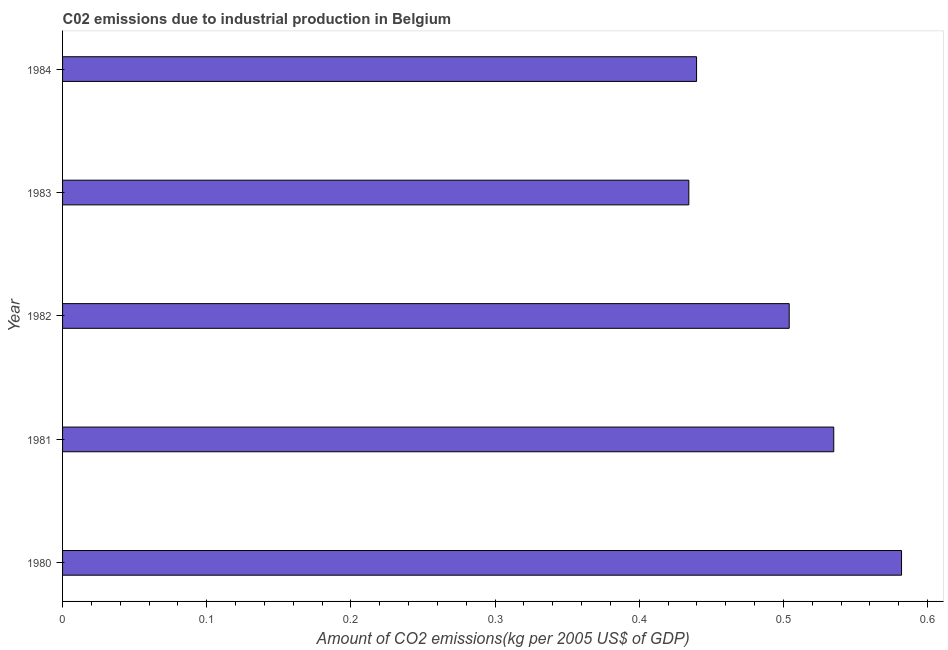Does the graph contain grids?
Provide a short and direct response. No. What is the title of the graph?
Ensure brevity in your answer.  C02 emissions due to industrial production in Belgium. What is the label or title of the X-axis?
Keep it short and to the point. Amount of CO2 emissions(kg per 2005 US$ of GDP). What is the amount of co2 emissions in 1984?
Your answer should be very brief. 0.44. Across all years, what is the maximum amount of co2 emissions?
Provide a succinct answer. 0.58. Across all years, what is the minimum amount of co2 emissions?
Ensure brevity in your answer.  0.43. What is the sum of the amount of co2 emissions?
Offer a very short reply. 2.49. What is the difference between the amount of co2 emissions in 1980 and 1981?
Provide a succinct answer. 0.05. What is the average amount of co2 emissions per year?
Provide a succinct answer. 0.5. What is the median amount of co2 emissions?
Provide a short and direct response. 0.5. Do a majority of the years between 1980 and 1981 (inclusive) have amount of co2 emissions greater than 0.32 kg per 2005 US$ of GDP?
Your answer should be compact. Yes. What is the ratio of the amount of co2 emissions in 1982 to that in 1983?
Provide a succinct answer. 1.16. Is the amount of co2 emissions in 1980 less than that in 1984?
Provide a short and direct response. No. What is the difference between the highest and the second highest amount of co2 emissions?
Offer a very short reply. 0.05. Is the sum of the amount of co2 emissions in 1982 and 1983 greater than the maximum amount of co2 emissions across all years?
Your response must be concise. Yes. What is the difference between the highest and the lowest amount of co2 emissions?
Offer a terse response. 0.15. In how many years, is the amount of co2 emissions greater than the average amount of co2 emissions taken over all years?
Offer a very short reply. 3. Are all the bars in the graph horizontal?
Your answer should be very brief. Yes. What is the Amount of CO2 emissions(kg per 2005 US$ of GDP) in 1980?
Keep it short and to the point. 0.58. What is the Amount of CO2 emissions(kg per 2005 US$ of GDP) in 1981?
Provide a succinct answer. 0.53. What is the Amount of CO2 emissions(kg per 2005 US$ of GDP) in 1982?
Your answer should be very brief. 0.5. What is the Amount of CO2 emissions(kg per 2005 US$ of GDP) in 1983?
Provide a short and direct response. 0.43. What is the Amount of CO2 emissions(kg per 2005 US$ of GDP) of 1984?
Provide a succinct answer. 0.44. What is the difference between the Amount of CO2 emissions(kg per 2005 US$ of GDP) in 1980 and 1981?
Provide a succinct answer. 0.05. What is the difference between the Amount of CO2 emissions(kg per 2005 US$ of GDP) in 1980 and 1982?
Keep it short and to the point. 0.08. What is the difference between the Amount of CO2 emissions(kg per 2005 US$ of GDP) in 1980 and 1983?
Your answer should be very brief. 0.15. What is the difference between the Amount of CO2 emissions(kg per 2005 US$ of GDP) in 1980 and 1984?
Your response must be concise. 0.14. What is the difference between the Amount of CO2 emissions(kg per 2005 US$ of GDP) in 1981 and 1982?
Provide a succinct answer. 0.03. What is the difference between the Amount of CO2 emissions(kg per 2005 US$ of GDP) in 1981 and 1983?
Offer a terse response. 0.1. What is the difference between the Amount of CO2 emissions(kg per 2005 US$ of GDP) in 1981 and 1984?
Your response must be concise. 0.1. What is the difference between the Amount of CO2 emissions(kg per 2005 US$ of GDP) in 1982 and 1983?
Your answer should be compact. 0.07. What is the difference between the Amount of CO2 emissions(kg per 2005 US$ of GDP) in 1982 and 1984?
Offer a terse response. 0.06. What is the difference between the Amount of CO2 emissions(kg per 2005 US$ of GDP) in 1983 and 1984?
Offer a very short reply. -0.01. What is the ratio of the Amount of CO2 emissions(kg per 2005 US$ of GDP) in 1980 to that in 1981?
Provide a succinct answer. 1.09. What is the ratio of the Amount of CO2 emissions(kg per 2005 US$ of GDP) in 1980 to that in 1982?
Offer a very short reply. 1.16. What is the ratio of the Amount of CO2 emissions(kg per 2005 US$ of GDP) in 1980 to that in 1983?
Offer a very short reply. 1.34. What is the ratio of the Amount of CO2 emissions(kg per 2005 US$ of GDP) in 1980 to that in 1984?
Ensure brevity in your answer.  1.32. What is the ratio of the Amount of CO2 emissions(kg per 2005 US$ of GDP) in 1981 to that in 1982?
Your answer should be very brief. 1.06. What is the ratio of the Amount of CO2 emissions(kg per 2005 US$ of GDP) in 1981 to that in 1983?
Provide a succinct answer. 1.23. What is the ratio of the Amount of CO2 emissions(kg per 2005 US$ of GDP) in 1981 to that in 1984?
Provide a short and direct response. 1.22. What is the ratio of the Amount of CO2 emissions(kg per 2005 US$ of GDP) in 1982 to that in 1983?
Your answer should be compact. 1.16. What is the ratio of the Amount of CO2 emissions(kg per 2005 US$ of GDP) in 1982 to that in 1984?
Offer a very short reply. 1.15. What is the ratio of the Amount of CO2 emissions(kg per 2005 US$ of GDP) in 1983 to that in 1984?
Your answer should be very brief. 0.99. 